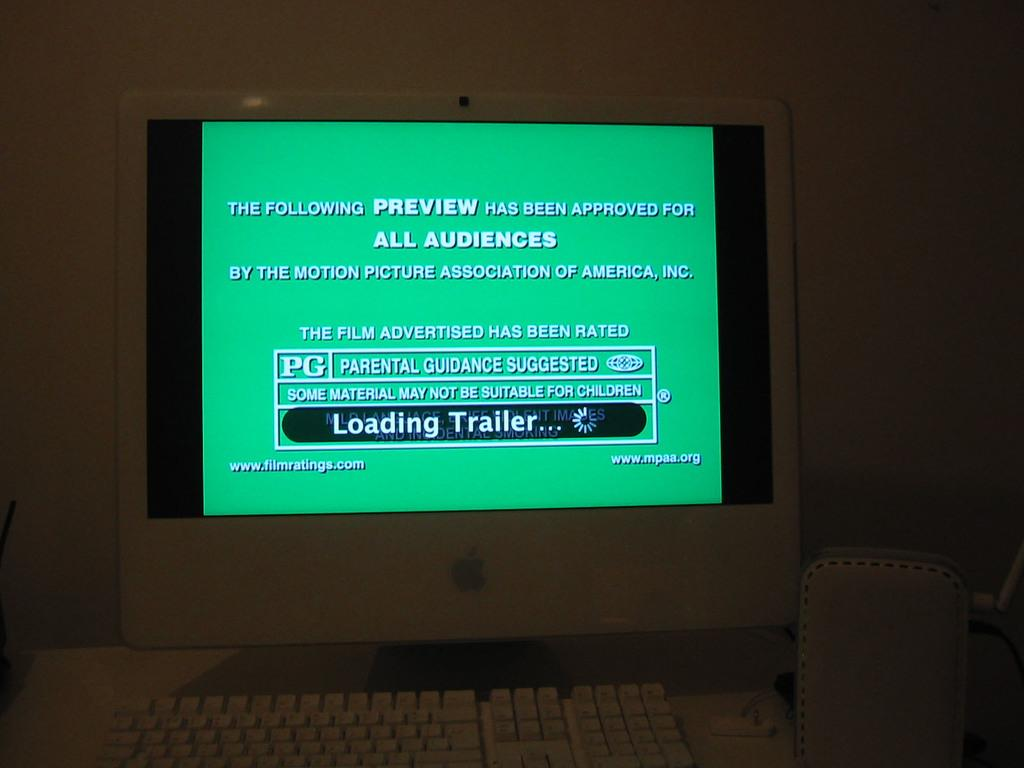<image>
Render a clear and concise summary of the photo. A computer monitor is loading a trailer that is read PG. 